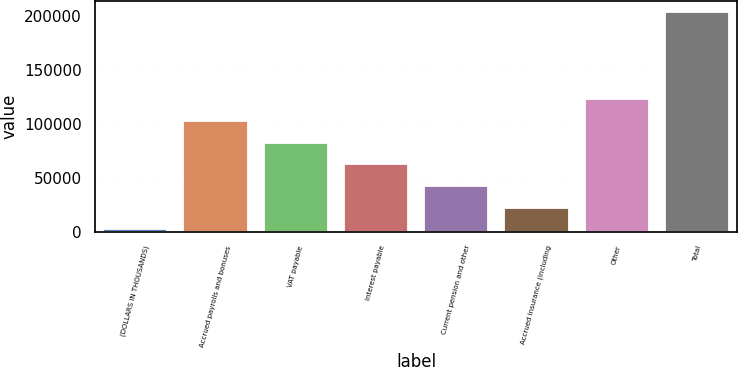Convert chart. <chart><loc_0><loc_0><loc_500><loc_500><bar_chart><fcel>(DOLLARS IN THOUSANDS)<fcel>Accrued payrolls and bonuses<fcel>VAT payable<fcel>Interest payable<fcel>Current pension and other<fcel>Accrued insurance (including<fcel>Other<fcel>Total<nl><fcel>2011<fcel>102923<fcel>82740.6<fcel>62558.2<fcel>42375.8<fcel>22193.4<fcel>123105<fcel>203835<nl></chart> 